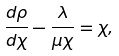<formula> <loc_0><loc_0><loc_500><loc_500>\frac { d \rho } { d \chi } - \frac { \lambda } { \mu \chi } = \chi ,</formula> 